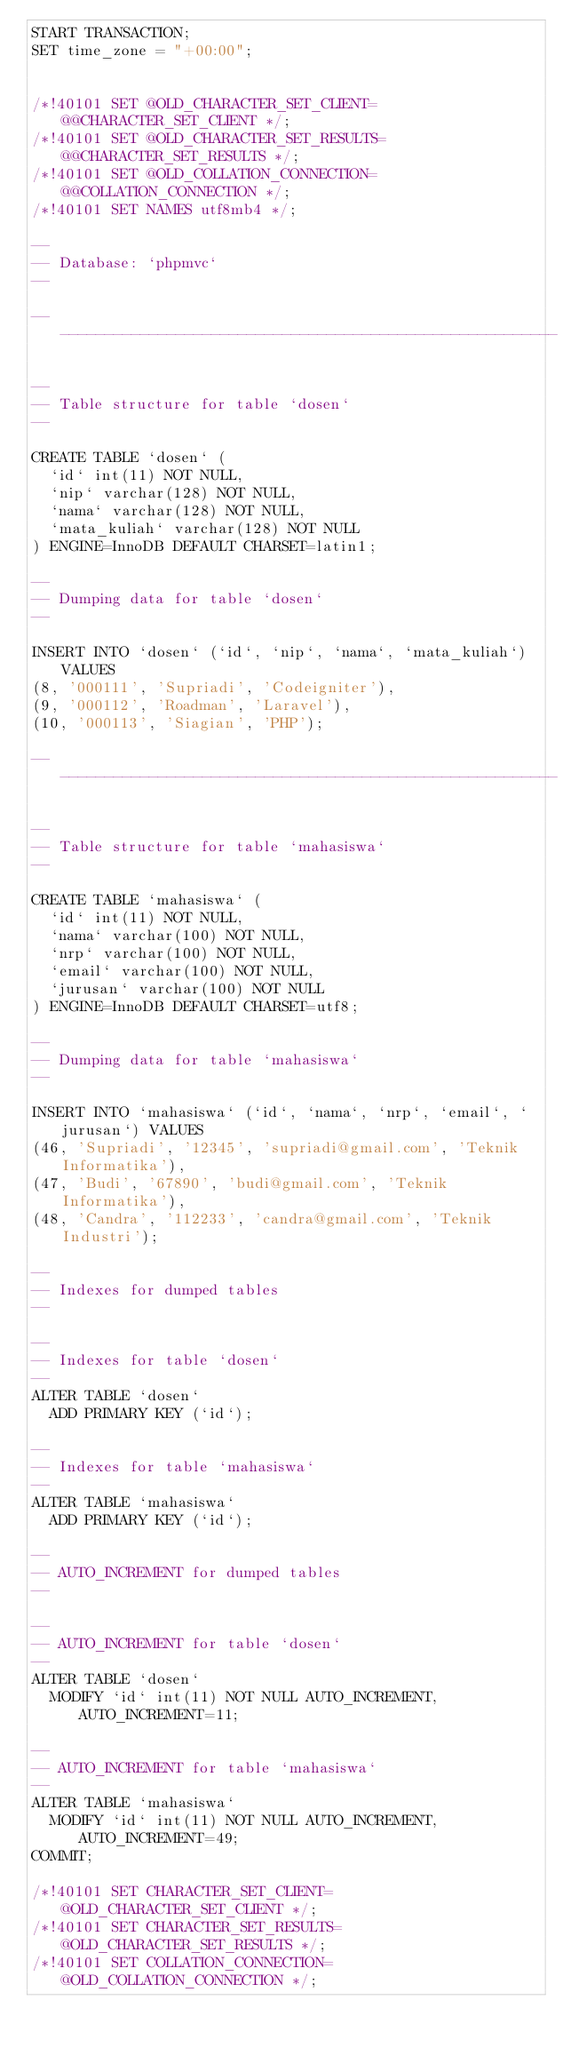<code> <loc_0><loc_0><loc_500><loc_500><_SQL_>START TRANSACTION;
SET time_zone = "+00:00";


/*!40101 SET @OLD_CHARACTER_SET_CLIENT=@@CHARACTER_SET_CLIENT */;
/*!40101 SET @OLD_CHARACTER_SET_RESULTS=@@CHARACTER_SET_RESULTS */;
/*!40101 SET @OLD_COLLATION_CONNECTION=@@COLLATION_CONNECTION */;
/*!40101 SET NAMES utf8mb4 */;

--
-- Database: `phpmvc`
--

-- --------------------------------------------------------

--
-- Table structure for table `dosen`
--

CREATE TABLE `dosen` (
  `id` int(11) NOT NULL,
  `nip` varchar(128) NOT NULL,
  `nama` varchar(128) NOT NULL,
  `mata_kuliah` varchar(128) NOT NULL
) ENGINE=InnoDB DEFAULT CHARSET=latin1;

--
-- Dumping data for table `dosen`
--

INSERT INTO `dosen` (`id`, `nip`, `nama`, `mata_kuliah`) VALUES
(8, '000111', 'Supriadi', 'Codeigniter'),
(9, '000112', 'Roadman', 'Laravel'),
(10, '000113', 'Siagian', 'PHP');

-- --------------------------------------------------------

--
-- Table structure for table `mahasiswa`
--

CREATE TABLE `mahasiswa` (
  `id` int(11) NOT NULL,
  `nama` varchar(100) NOT NULL,
  `nrp` varchar(100) NOT NULL,
  `email` varchar(100) NOT NULL,
  `jurusan` varchar(100) NOT NULL
) ENGINE=InnoDB DEFAULT CHARSET=utf8;

--
-- Dumping data for table `mahasiswa`
--

INSERT INTO `mahasiswa` (`id`, `nama`, `nrp`, `email`, `jurusan`) VALUES
(46, 'Supriadi', '12345', 'supriadi@gmail.com', 'Teknik Informatika'),
(47, 'Budi', '67890', 'budi@gmail.com', 'Teknik Informatika'),
(48, 'Candra', '112233', 'candra@gmail.com', 'Teknik Industri');

--
-- Indexes for dumped tables
--

--
-- Indexes for table `dosen`
--
ALTER TABLE `dosen`
  ADD PRIMARY KEY (`id`);

--
-- Indexes for table `mahasiswa`
--
ALTER TABLE `mahasiswa`
  ADD PRIMARY KEY (`id`);

--
-- AUTO_INCREMENT for dumped tables
--

--
-- AUTO_INCREMENT for table `dosen`
--
ALTER TABLE `dosen`
  MODIFY `id` int(11) NOT NULL AUTO_INCREMENT, AUTO_INCREMENT=11;

--
-- AUTO_INCREMENT for table `mahasiswa`
--
ALTER TABLE `mahasiswa`
  MODIFY `id` int(11) NOT NULL AUTO_INCREMENT, AUTO_INCREMENT=49;
COMMIT;

/*!40101 SET CHARACTER_SET_CLIENT=@OLD_CHARACTER_SET_CLIENT */;
/*!40101 SET CHARACTER_SET_RESULTS=@OLD_CHARACTER_SET_RESULTS */;
/*!40101 SET COLLATION_CONNECTION=@OLD_COLLATION_CONNECTION */;
</code> 